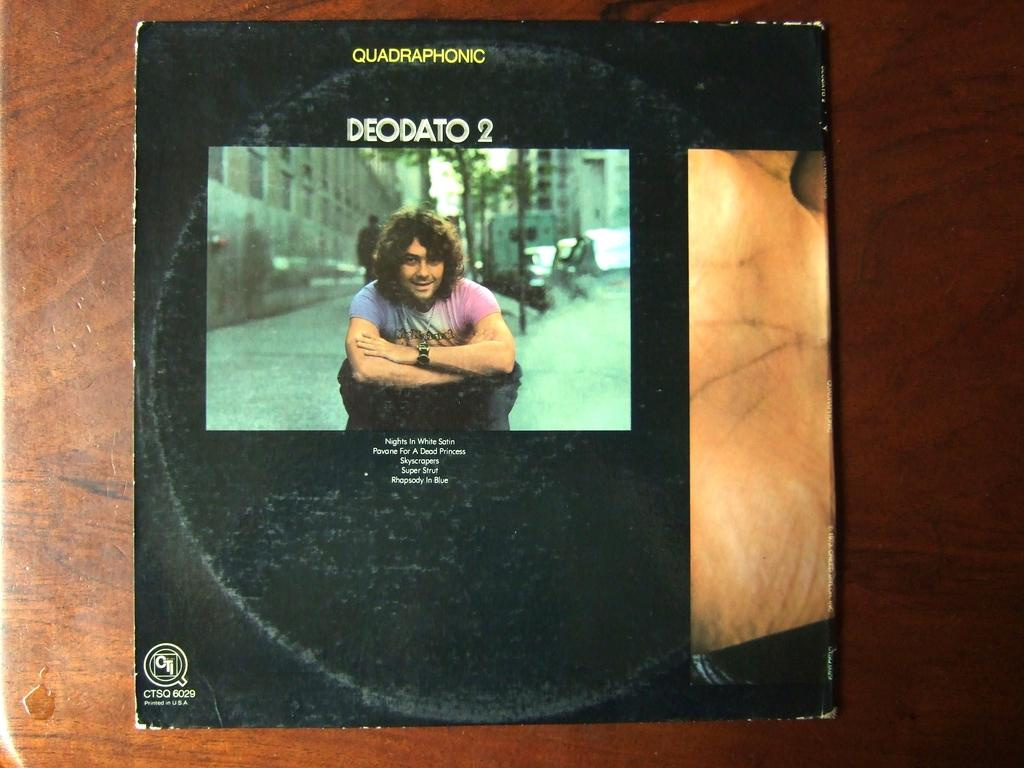What is the main subject of the photo frame in the image? There is a photo frame of a person in the image. What type of structures can be seen in the image? There are buildings visible in the image. What type of vegetation is present in the image? There are trees in the image. How many people are visible in the image? There is a crowd in the image, indicating that multiple people are present. Where might the image have been taken? The image is likely taken in a room, as there are no outdoor elements like sky or clouds visible. What type of wine is being served in the image? There is no wine present in the image; it features a photo frame, buildings, trees, and a crowd. How many straws are visible in the image? There are no straws visible in the image. 